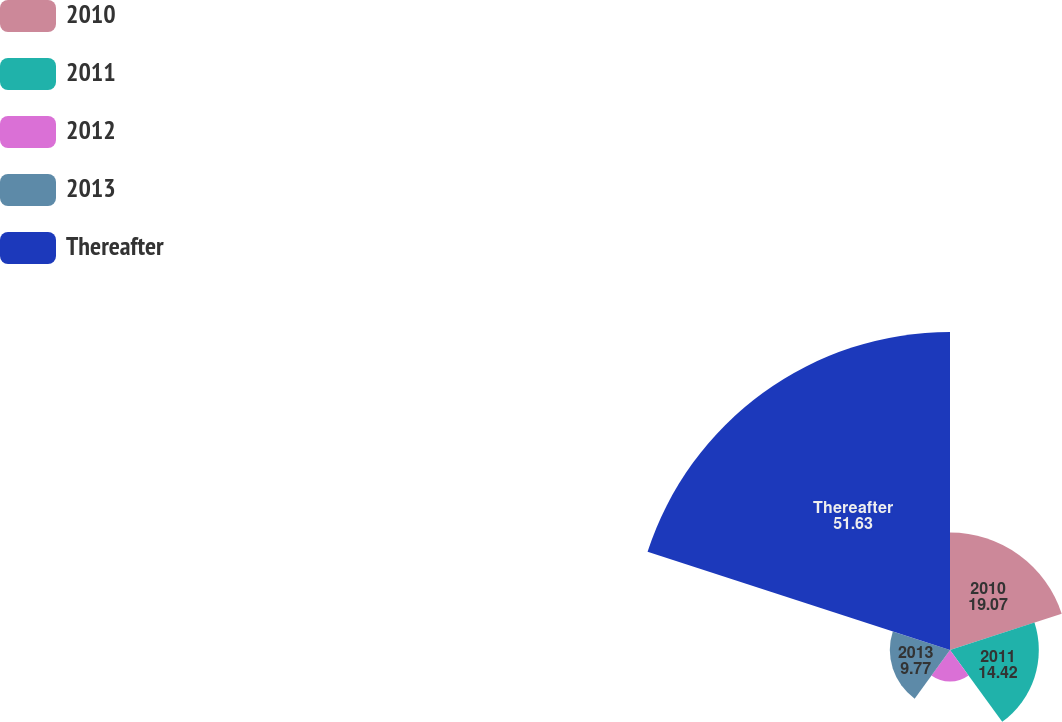Convert chart. <chart><loc_0><loc_0><loc_500><loc_500><pie_chart><fcel>2010<fcel>2011<fcel>2012<fcel>2013<fcel>Thereafter<nl><fcel>19.07%<fcel>14.42%<fcel>5.12%<fcel>9.77%<fcel>51.63%<nl></chart> 